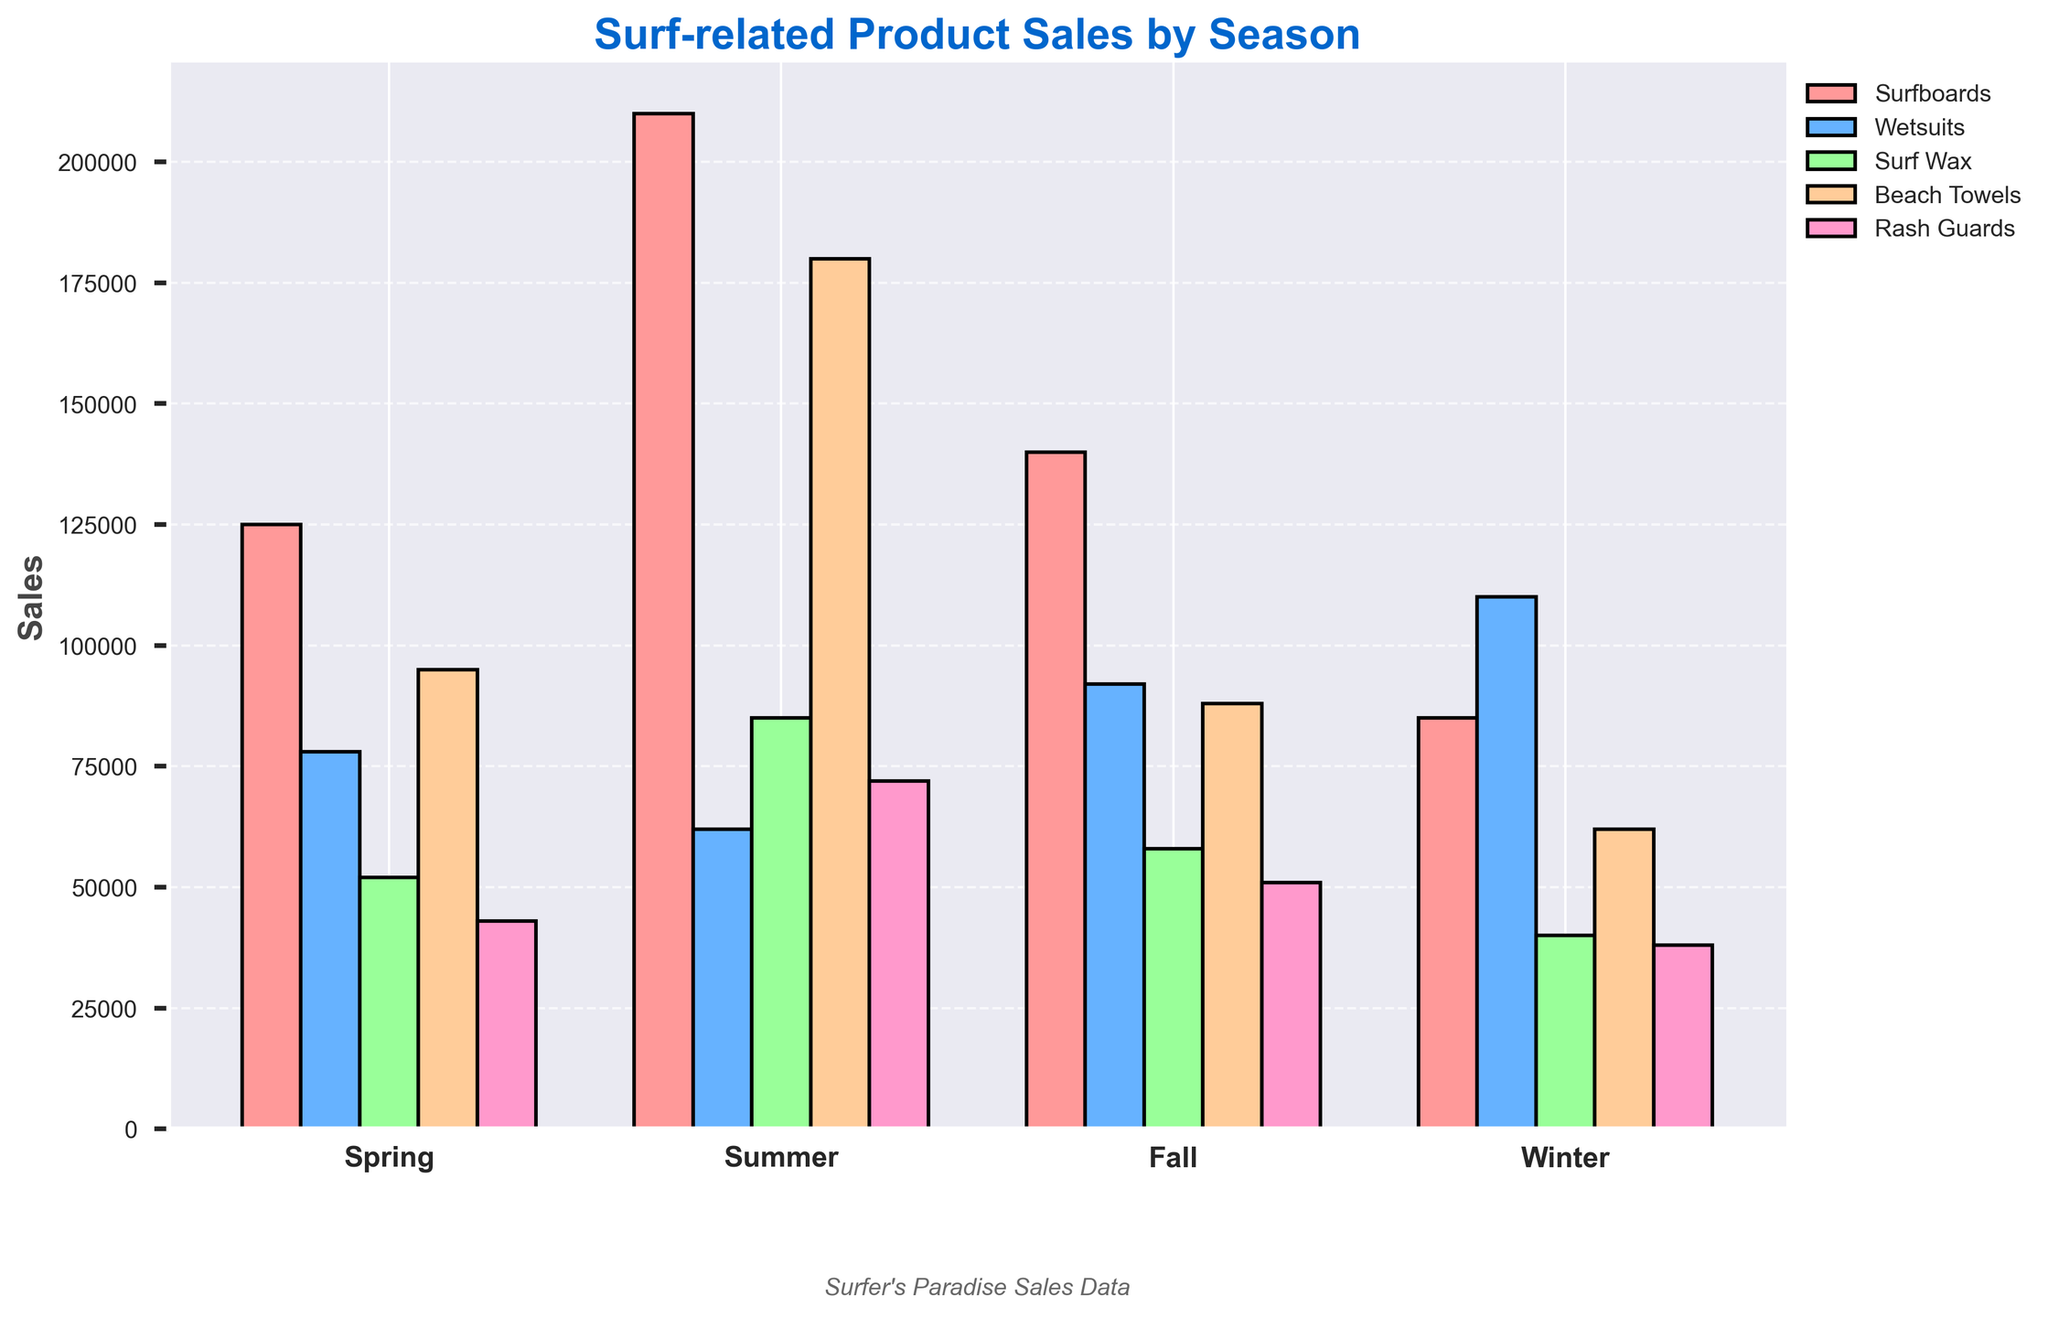Which season had the highest sales for surfboards? To find this, compare the heights of the bars corresponding to "Surfboards" in each season. The tallest bar represents the highest sales. Summer has the highest bar for surfboards at 210,000.
Answer: Summer Which product had the highest sales overall in Summer? Look at the height of each bar for all products in the summer. The highest bar indicates the product with the highest sales. Beach Towels had the highest sales in Summer with 180,000.
Answer: Beach Towels How much more were winter wetsuit sales compared to summer wetsuit sales? Locate the bars for wetsuits in both winter and summer. Subtract the summer sales (62,000) from the winter sales (110,000). This results in 48,000.
Answer: 48,000 In which season were sales of surf wax the lowest? Compare the heights of the surf wax bars across all seasons. The shortest bar represents the lowest sales. Winter had the lowest sales with 40,000.
Answer: Winter What is the total sales of beach towels across all seasons? Sum the sales of beach towels for each season: 95,000 (Spring) + 180,000 (Summer) + 88,000 (Fall) + 62,000 (Winter). This results in a total of 425,000.
Answer: 425,000 Which product had the most increase in sales from Spring to Summer? Subtract the Spring sales from the Summer sales for each product. Compare the differences: Surfboards: 210,000 - 125,000 = 85,000; Wetsuits: 62,000 - 78,000 = -16,000; Surf Wax: 85,000 - 52,000 = 33,000; Beach Towels: 180,000 - 95,000 = 85,000; Rash Guards: 72,000 - 43,000 = 29,000. Both Surfboards and Beach Towels had an increase of 85,000.
Answer: Surfboards and Beach Towels What was the combined sales of surfboards and wetsuits in Fall? Add the fall sales for surfboards (140,000) and wetsuits (92,000). The total combined sales are 232,000.
Answer: 232,000 How do winter rash guard sales compare to summer rash guard sales? Look at the bars for rash guards in winter and summer. Comparing the heights, winter sales (38,000) are less than summer sales (72,000).
Answer: Less than By how much do summer sales of beach towels exceed spring sales? Locate the bars for beach towels in summer and spring. Subtract the spring sales (95,000) from the summer sales (180,000). The difference is 85,000.
Answer: 85,000 Which season had the lowest total sales across all products? Sum the sales of all products for each season. Spring: 125,000 + 78,000 + 52,000 + 95,000 + 43,000 = 393,000; Summer: 210,000 + 62,000 + 85,000 + 180,000 + 72,000 = 609,000; Fall: 140,000 + 92,000 + 58,000 + 88,000 + 51,000 = 429,000; Winter: 85,000 + 110,000 + 40,000 + 62,000 + 38,000 = 335,000. Winter has the lowest total sales with 335,000.
Answer: Winter 